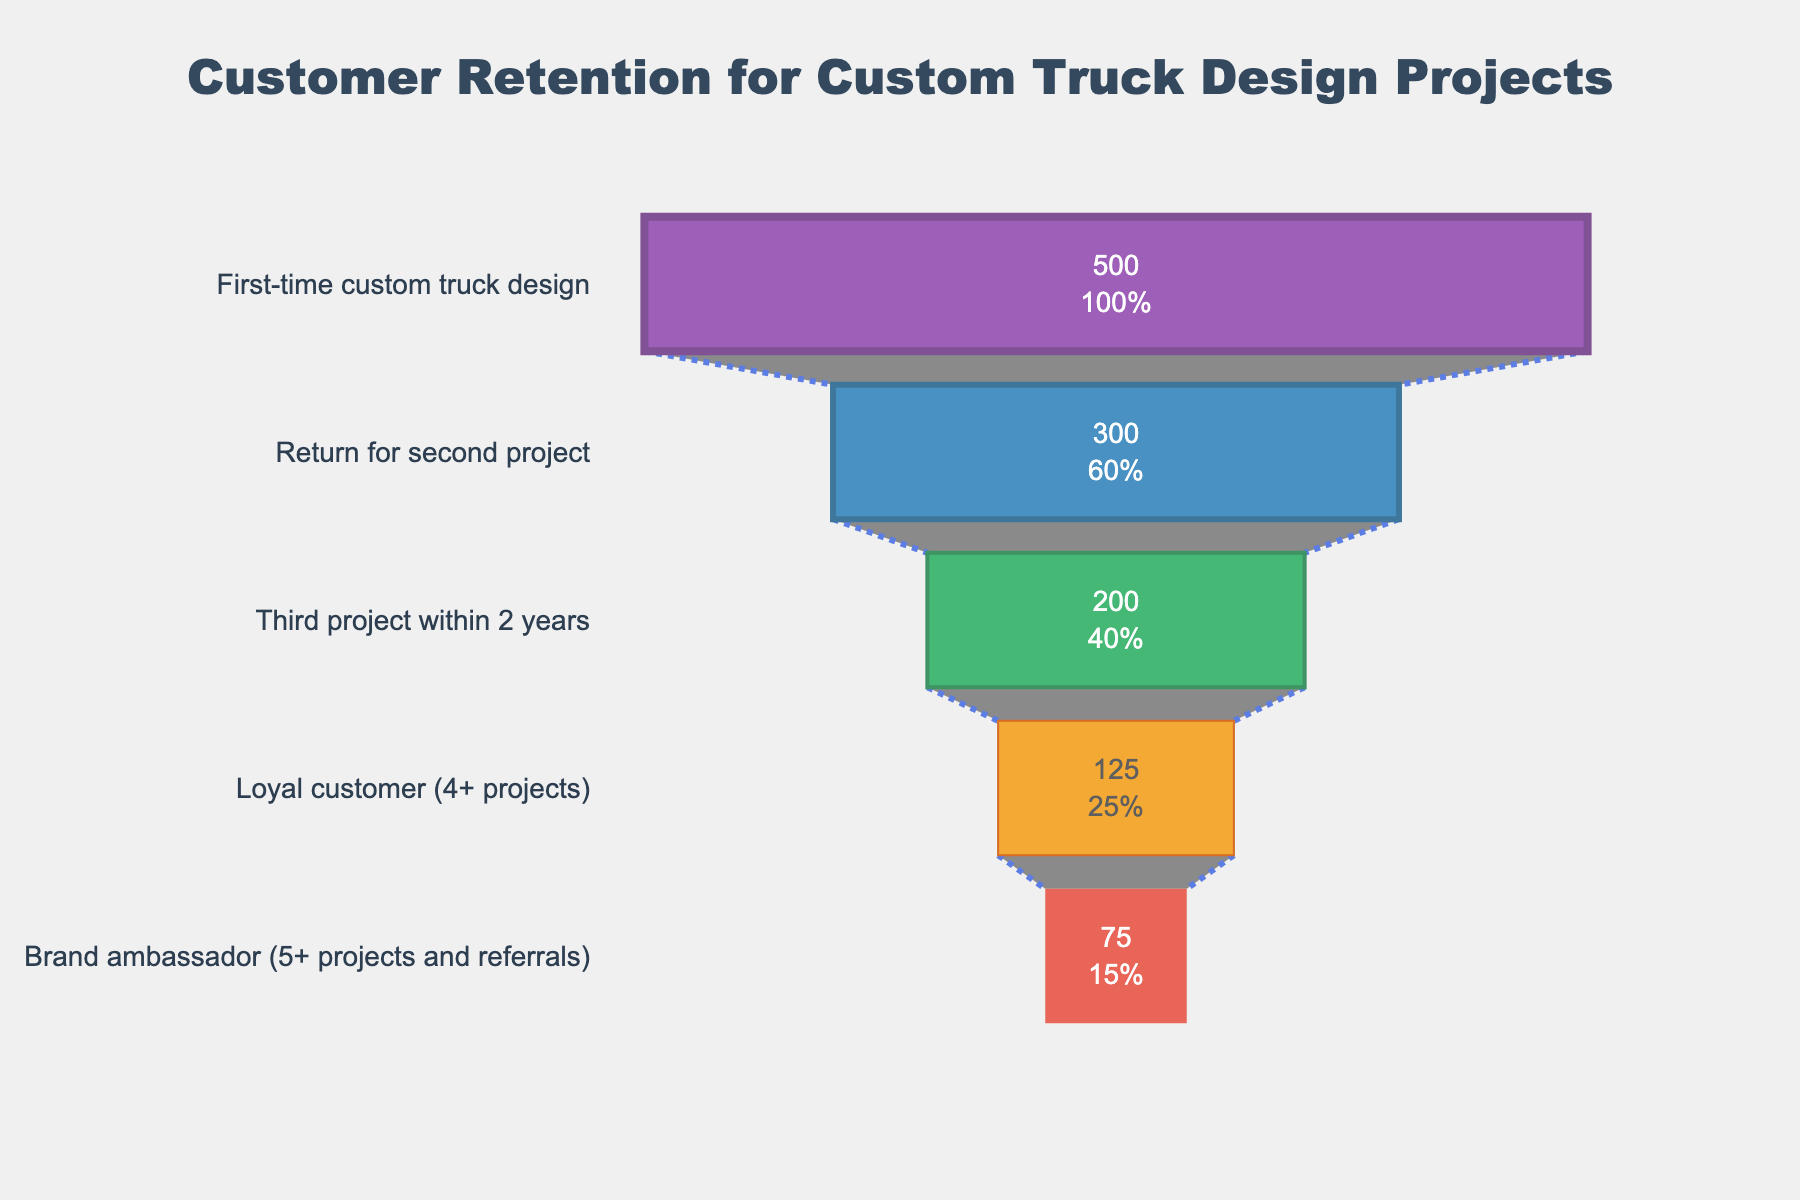What is the title of the figure? The title of the figure is displayed prominently at the top and reads "Customer Retention for Custom Truck Design Projects".
Answer: Customer Retention for Custom Truck Design Projects How many stages are shown in the funnel chart? The funnel chart lists 5 stages which are visible on the y-axis.
Answer: 5 How many customers returned for a second project? According to the second stage on the funnel chart labeled "Return for second project", there are 300 customers.
Answer: 300 What percentage of customers become brand ambassadors? The last stage of the funnel chart "Brand ambassador" shows that 15% of customers become brand ambassadors.
Answer: 15% What is the difference in the number of customers between those who return for a second project and those who become loyal customers? The number of customers who return for a second project is 300, and those who become loyal customers are 125. The difference is 300 - 125 = 175.
Answer: 175 Compare the number of first-time custom truck design customers to loyal customers. The number of first-time custom truck design customers is 500, and the number of loyal customers is 125. The first-time customers outnumber the loyal customers by 500 - 125 = 375.
Answer: 375 Among the stages listed, which one has the lowest percentage of customers? The stage "Brand ambassador" has the lowest percentage of customers at 15%, as seen in the funnel chart.
Answer: Brand ambassador What is the total number of customers who have completed at least three projects within 2 years? According to the funnel chart, 200 customers have completed at least three projects within 2 years.
Answer: 200 Calculate the average percentage of customers retained across all stages. Sum the percentages for all stages: 100% + 60% + 40% + 25% + 15% = 240%. Divide by the number of stages (5): 240% / 5 = 48%.
Answer: 48% What stage contributes to a 25% reduction in customer numbers? The transition from "Third project within 2 years" (40%) to "Loyal customer" (25%) shows a 15% reduction. However, only one stage, "Third project within 2 years", contributes to 25% of the total customer reduction.
Answer: Third project within 2 years 